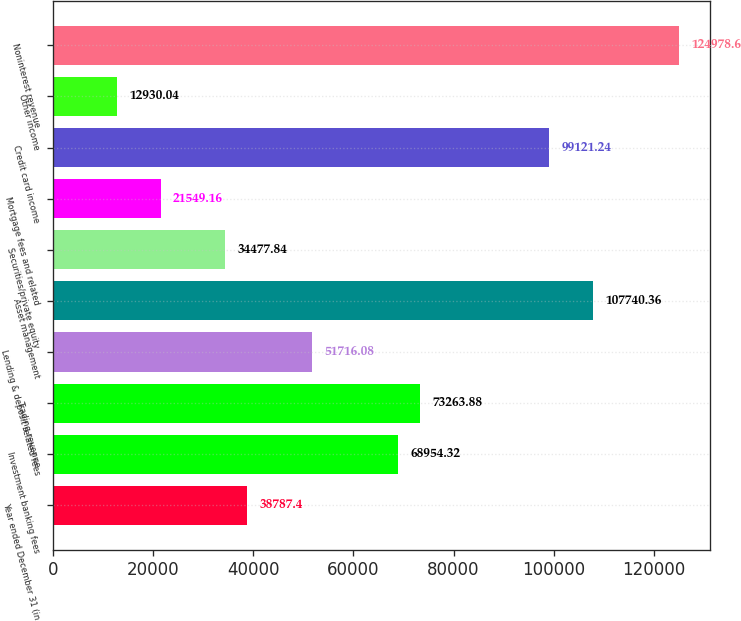Convert chart to OTSL. <chart><loc_0><loc_0><loc_500><loc_500><bar_chart><fcel>Year ended December 31 (in<fcel>Investment banking fees<fcel>Trading revenue<fcel>Lending & deposit related fees<fcel>Asset management<fcel>Securities/private equity<fcel>Mortgage fees and related<fcel>Credit card income<fcel>Other income<fcel>Noninterest revenue<nl><fcel>38787.4<fcel>68954.3<fcel>73263.9<fcel>51716.1<fcel>107740<fcel>34477.8<fcel>21549.2<fcel>99121.2<fcel>12930<fcel>124979<nl></chart> 